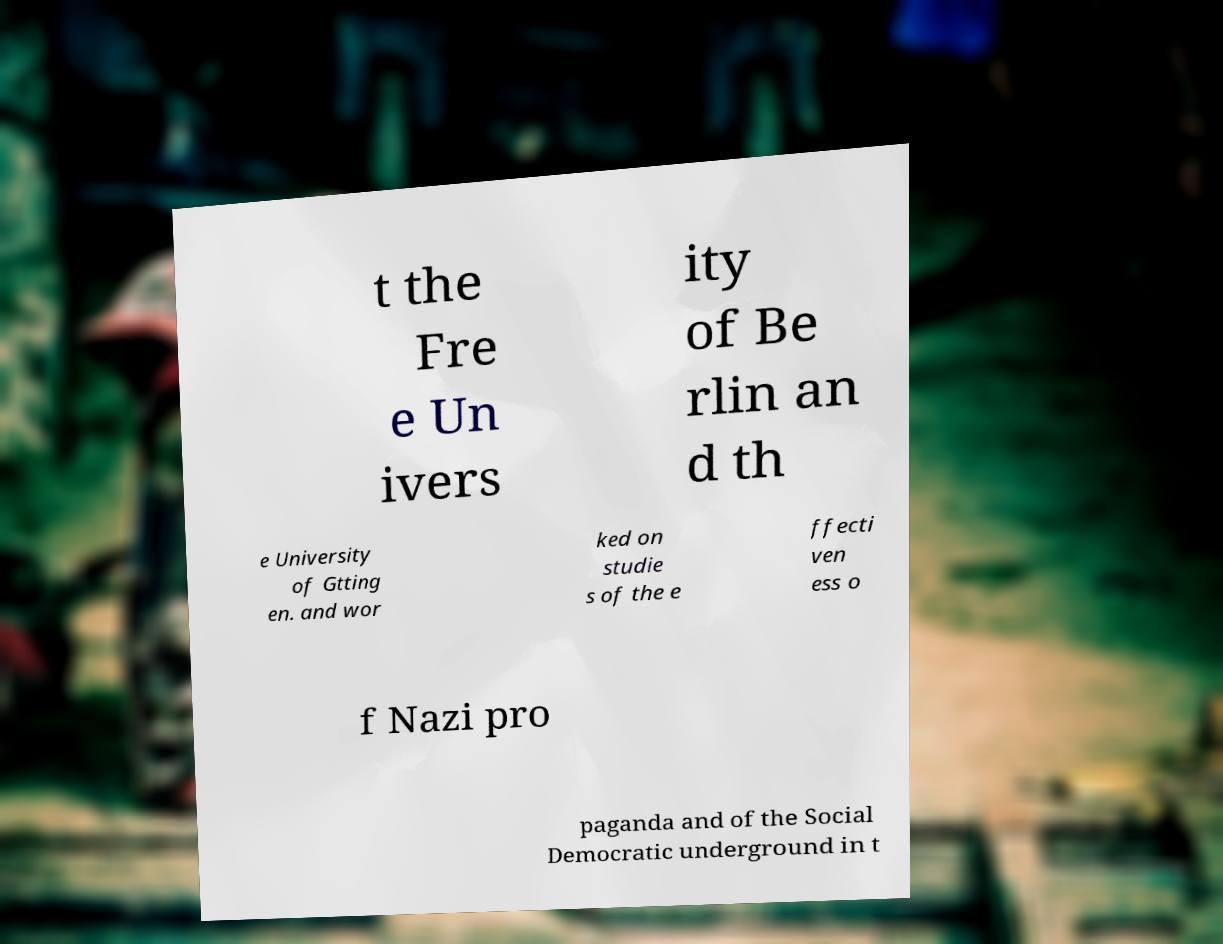Could you extract and type out the text from this image? t the Fre e Un ivers ity of Be rlin an d th e University of Gtting en. and wor ked on studie s of the e ffecti ven ess o f Nazi pro paganda and of the Social Democratic underground in t 